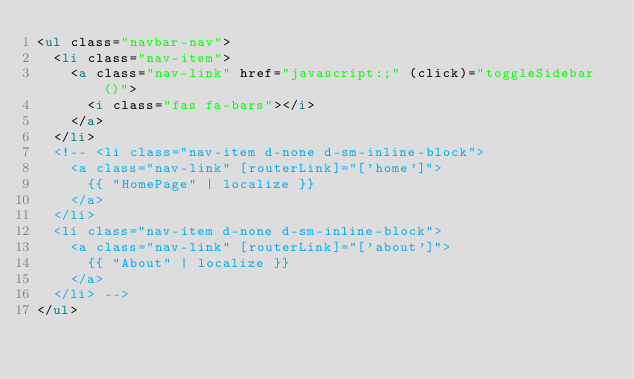Convert code to text. <code><loc_0><loc_0><loc_500><loc_500><_HTML_><ul class="navbar-nav">
  <li class="nav-item">
    <a class="nav-link" href="javascript:;" (click)="toggleSidebar()">
      <i class="fas fa-bars"></i>
    </a>
  </li>
  <!-- <li class="nav-item d-none d-sm-inline-block">
    <a class="nav-link" [routerLink]="['home']">
      {{ "HomePage" | localize }}
    </a>
  </li>
  <li class="nav-item d-none d-sm-inline-block">
    <a class="nav-link" [routerLink]="['about']">
      {{ "About" | localize }}
    </a>
  </li> -->
</ul>
</code> 